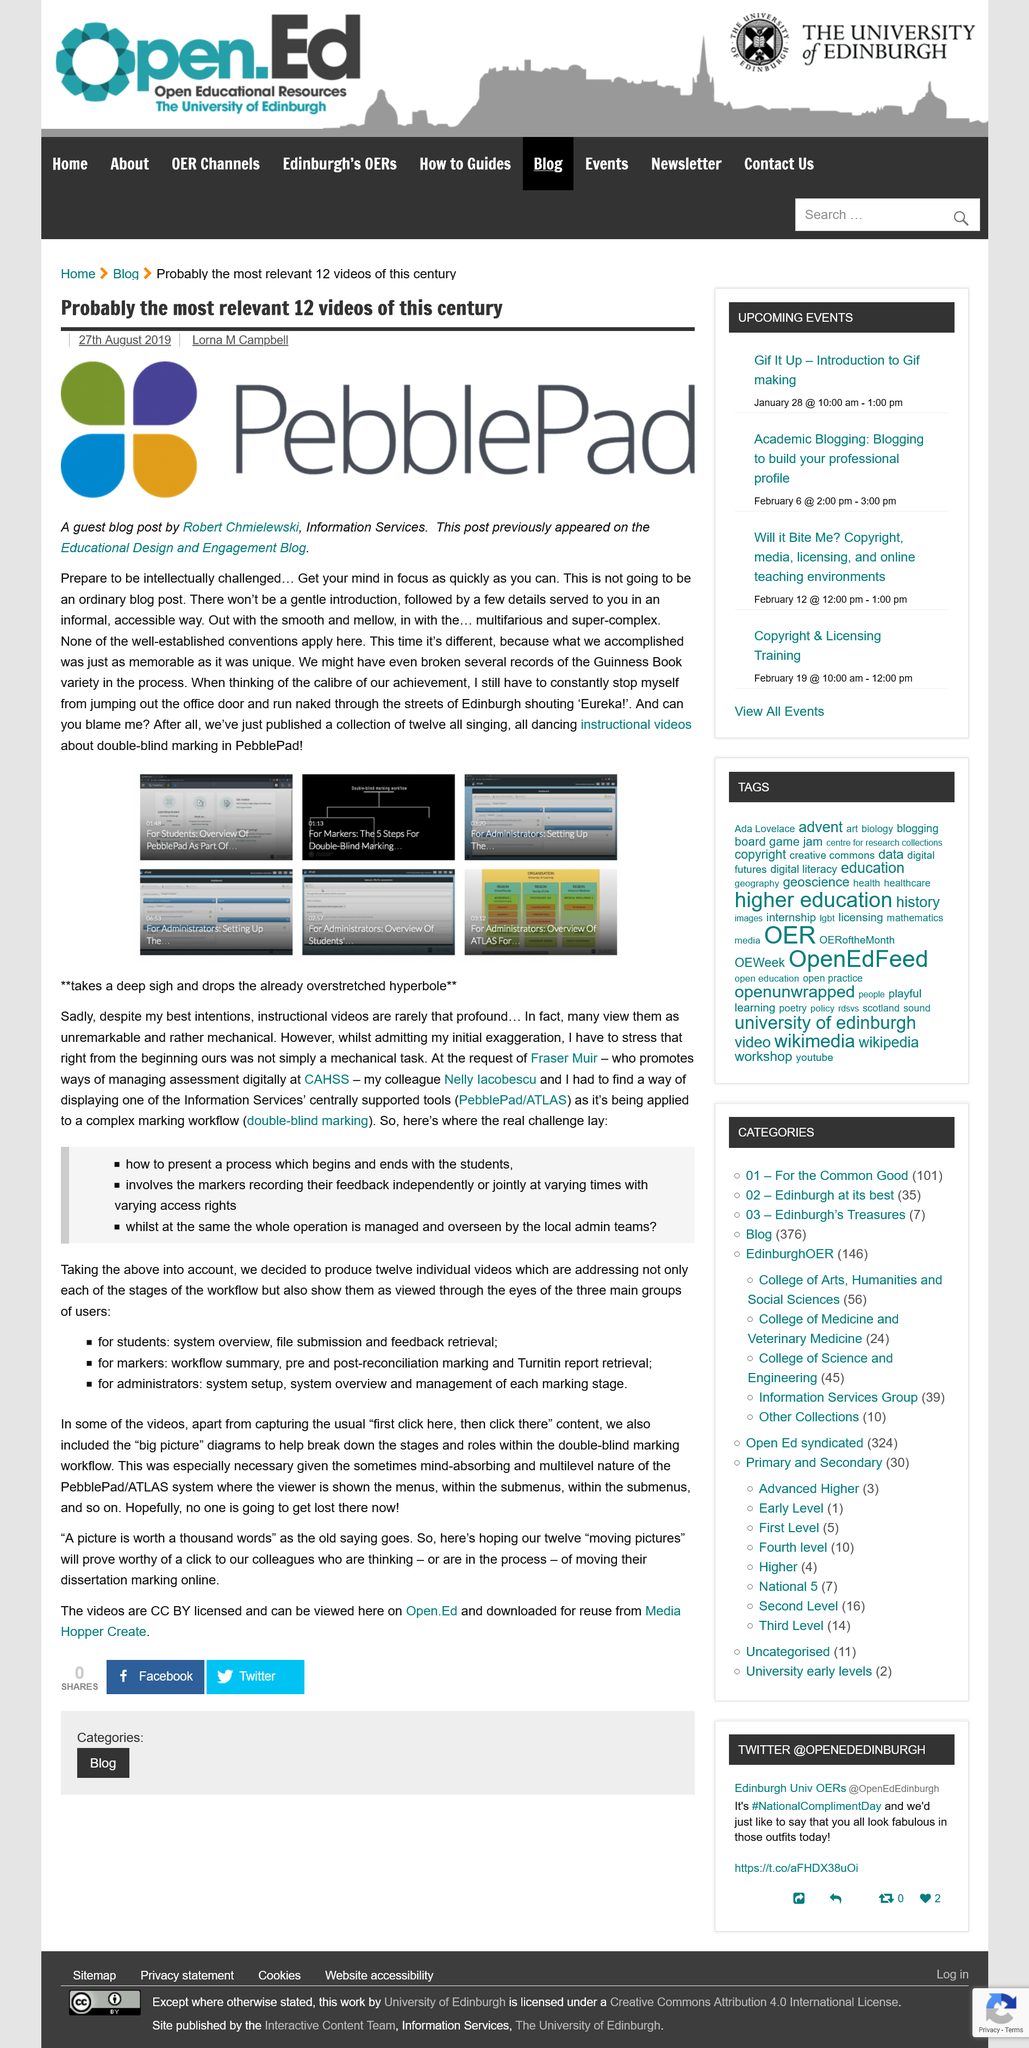Point out several critical features in this image. The three main groups of users are students, markers, and administrators. The author of the guest blog post is Robert Chmielewski. The user group concerned with system overview, file submission, and feedback retrieval is students. The article 'Probably the most relevant 12 videos of this century' was published on August 27, 2019. The real challenge contains 3 bullet points. 